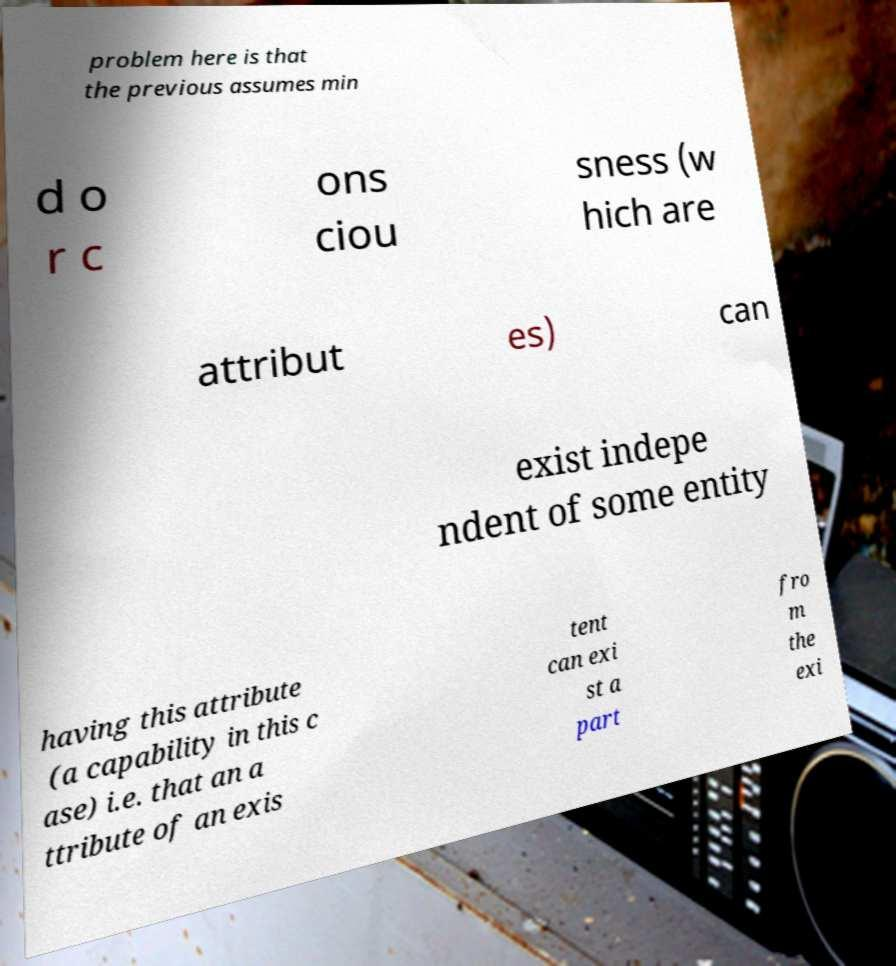Please read and relay the text visible in this image. What does it say? problem here is that the previous assumes min d o r c ons ciou sness (w hich are attribut es) can exist indepe ndent of some entity having this attribute (a capability in this c ase) i.e. that an a ttribute of an exis tent can exi st a part fro m the exi 